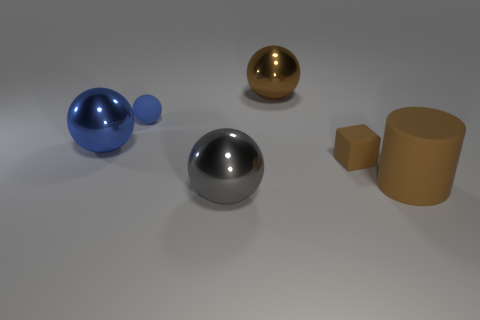There is a tiny blue thing; is it the same shape as the tiny thing that is right of the big gray shiny thing?
Keep it short and to the point. No. How many things are tiny things behind the small brown block or big gray metal blocks?
Your answer should be compact. 1. Is there anything else that is made of the same material as the large blue thing?
Provide a short and direct response. Yes. How many objects are behind the large blue object and right of the blue rubber object?
Make the answer very short. 1. What number of objects are balls behind the tiny brown rubber cube or matte things that are on the right side of the large brown sphere?
Your answer should be compact. 5. How many other things are the same shape as the blue rubber object?
Offer a very short reply. 3. There is a metallic thing to the left of the gray object; does it have the same color as the tiny sphere?
Make the answer very short. Yes. How many other objects are the same size as the matte cylinder?
Provide a succinct answer. 3. Does the small brown object have the same material as the cylinder?
Your answer should be compact. Yes. There is a large metal thing in front of the large brown thing in front of the blue metallic object; what is its color?
Your answer should be compact. Gray. 